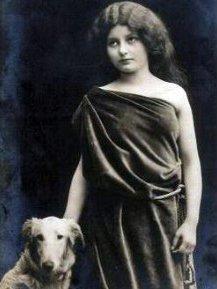Is this a painting?
Quick response, please. No. Is this a modern photograph?
Give a very brief answer. No. How many dogs are in the photo?
Concise answer only. 1. 